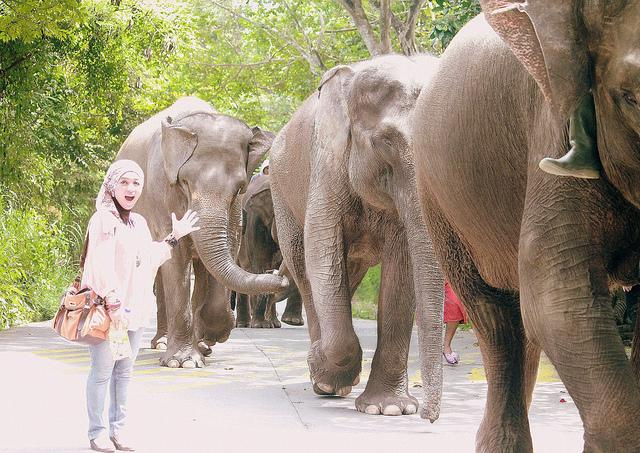What does this animal tend to have? Please explain your reasoning. two trunks. The animal has two tusks. 